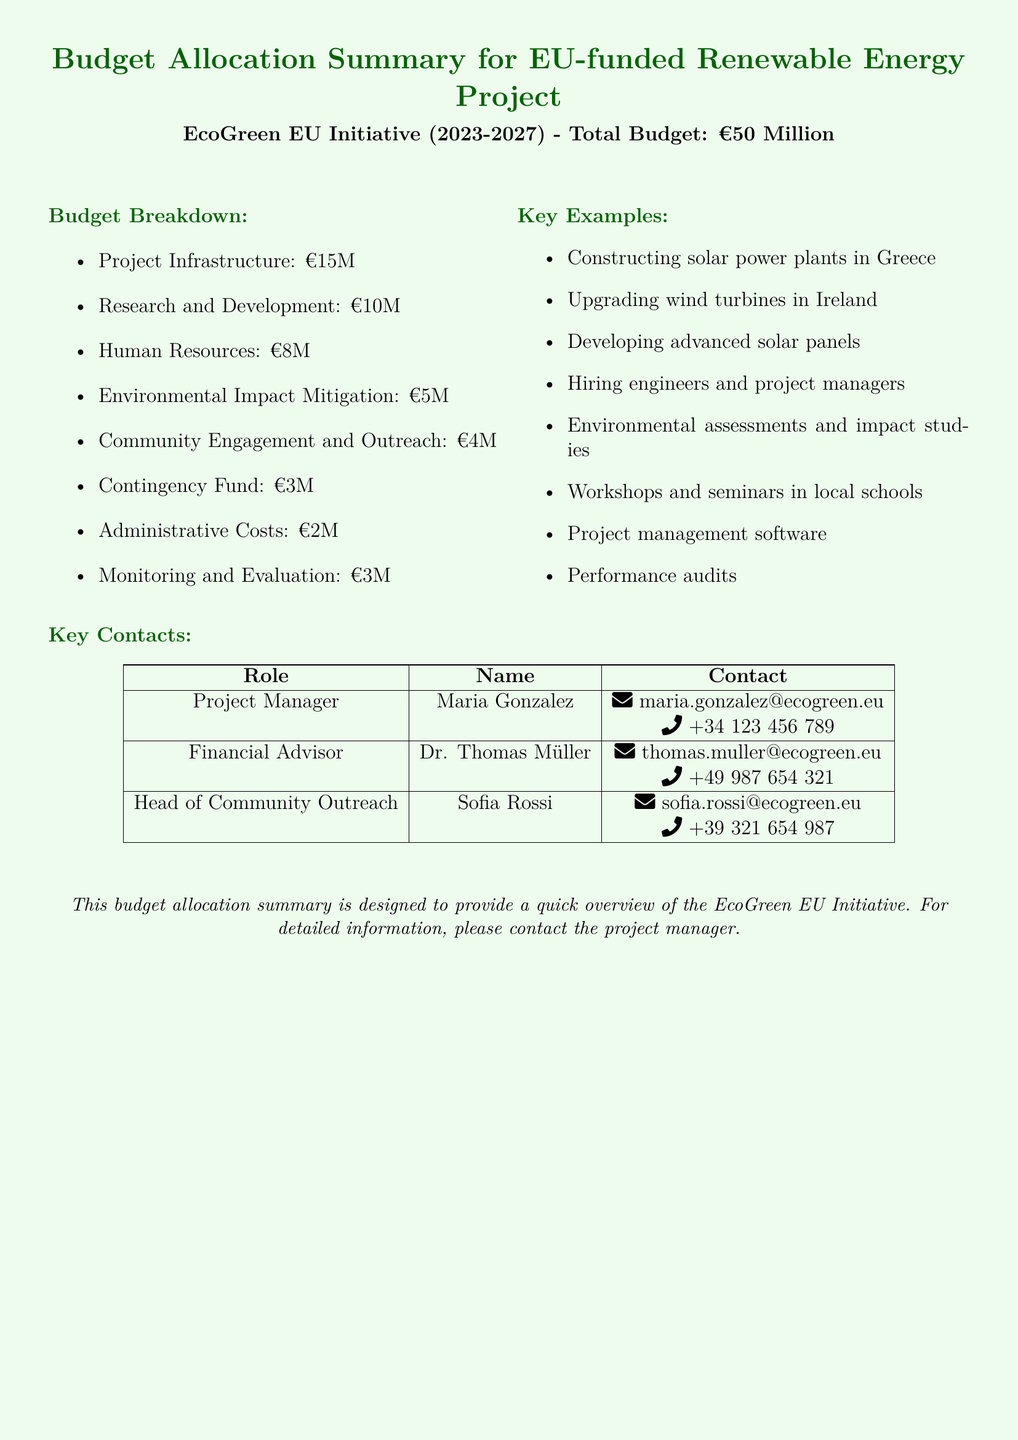What is the total budget for the EcoGreen EU Initiative? The total budget is explicitly stated in the document as €50 Million.
Answer: €50 Million How much is allocated for Project Infrastructure? The budget breakdown shows that €15 Million is allocated for Project Infrastructure.
Answer: €15 Million Who is the Project Manager? The document lists Maria Gonzalez as the Project Manager.
Answer: Maria Gonzalez What is the amount set aside for the Contingency Fund? The budget breakdown specifies that €3 Million is allocated for the Contingency Fund.
Answer: €3 Million Which country is mentioned for constructing solar power plants? The document notes that solar power plants are to be constructed in Greece.
Answer: Greece What is the total amount allocated for Community Engagement and Outreach? The budget breakdown states that €4 Million is allocated for Community Engagement and Outreach.
Answer: €4 Million Who is the Head of Community Outreach? The document identifies Sofia Rossi as the Head of Community Outreach.
Answer: Sofia Rossi How much money is allocated for Human Resources? According to the budget breakdown, €8 Million is allocated for Human Resources.
Answer: €8 Million What type of assessments will be conducted as part of the project? The document mentions that environmental assessments and impact studies will be conducted.
Answer: Environmental assessments and impact studies 